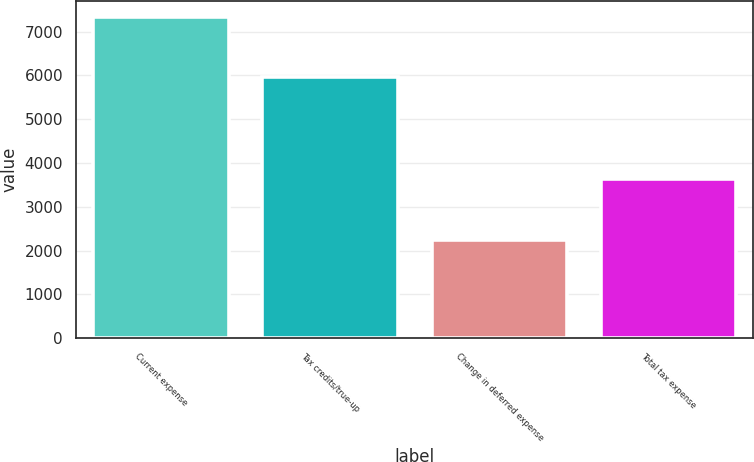<chart> <loc_0><loc_0><loc_500><loc_500><bar_chart><fcel>Current expense<fcel>Tax credits/true-up<fcel>Change in deferred expense<fcel>Total tax expense<nl><fcel>7339<fcel>5956<fcel>2242<fcel>3625<nl></chart> 